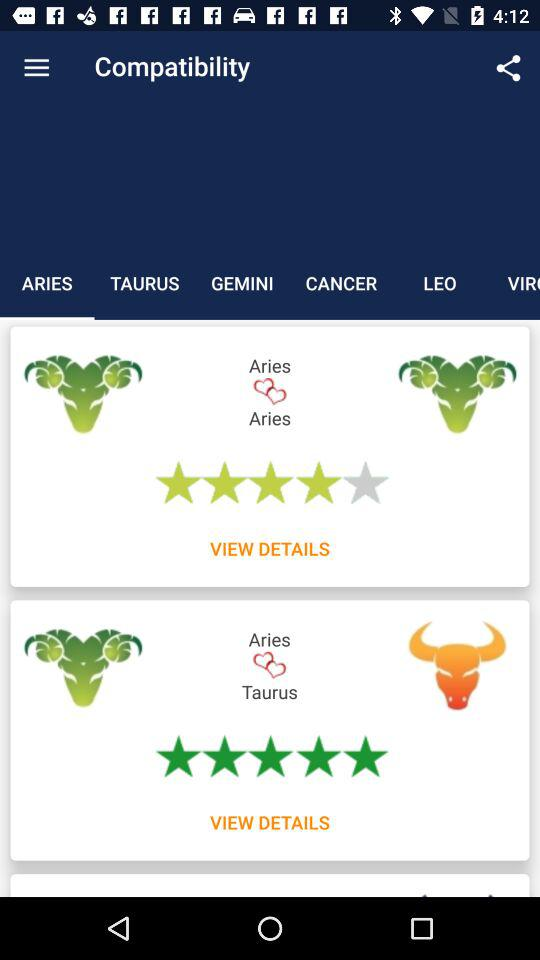How many stars are there for Aries and Taurus? There are 5 stars. 